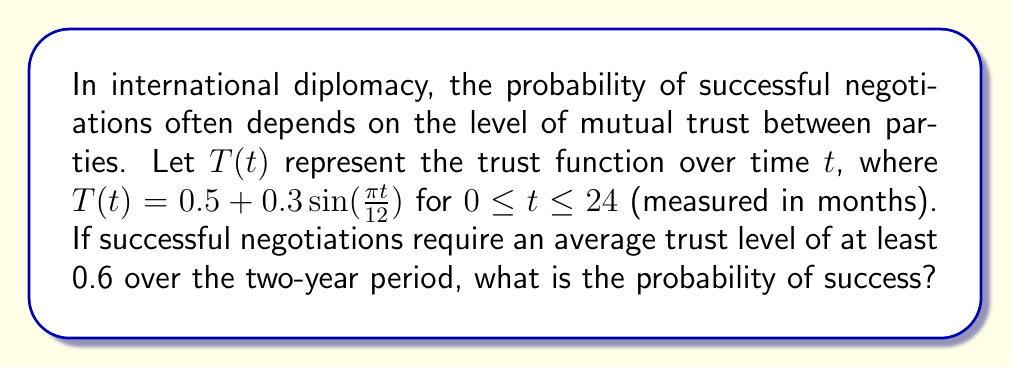Could you help me with this problem? To solve this problem, we need to follow these steps:

1) First, we need to calculate the average trust level over the two-year period. This can be done by integrating the trust function and dividing by the total time:

   Average Trust = $\frac{1}{24} \int_0^{24} T(t) dt$

2) Let's integrate $T(t)$:

   $\int_0^{24} T(t) dt = \int_0^{24} (0.5 + 0.3\sin(\frac{\pi t}{12})) dt$
   
   $= [0.5t - \frac{3.6}{\pi}\cos(\frac{\pi t}{12})]_0^{24}$
   
   $= (12 - \frac{3.6}{\pi}\cos(2\pi)) - (0 - \frac{3.6}{\pi}\cos(0))$
   
   $= 12 - \frac{3.6}{\pi}\cos(2\pi) + \frac{3.6}{\pi}$
   
   $= 12 + \frac{3.6}{\pi}(1 - \cos(2\pi))$
   
   $= 12$ (since $\cos(2\pi) = 1$)

3) Now, we can calculate the average trust:

   Average Trust = $\frac{1}{24} * 12 = 0.5$

4) The question asks for the probability of success, which requires an average trust level of at least 0.6. Since our calculated average (0.5) is less than 0.6, the probability of success is 0.
Answer: 0 